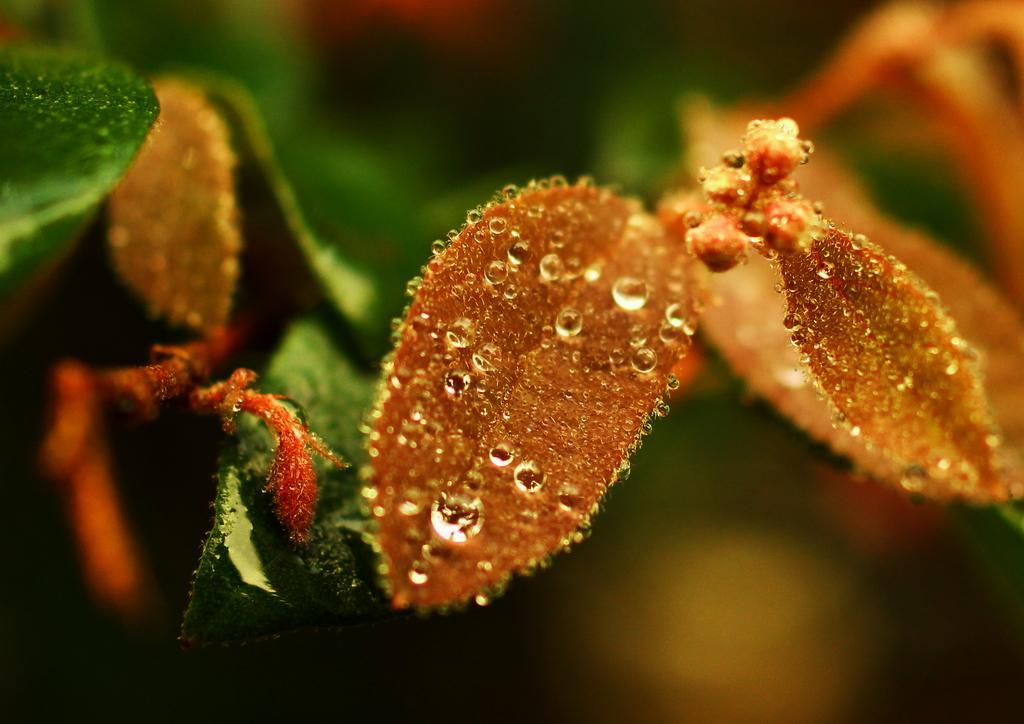How would you summarize this image in a sentence or two? These are the green leaves of a plant with water drops. 